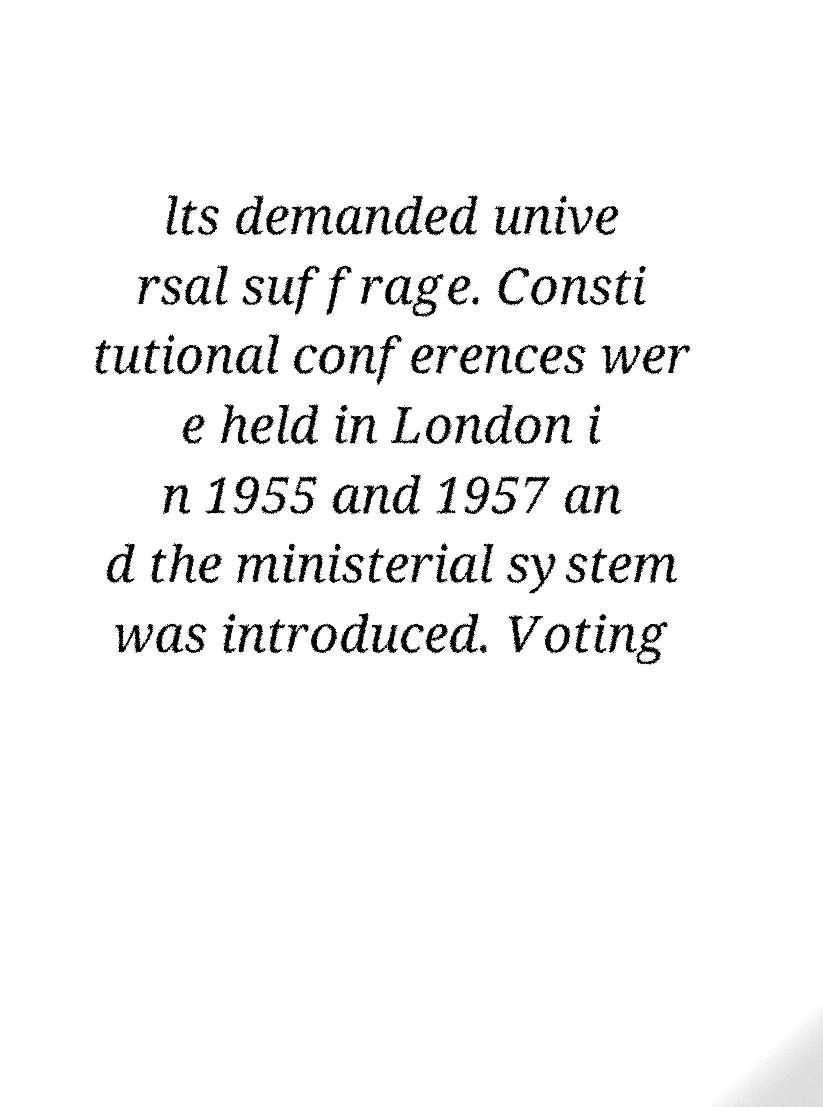For documentation purposes, I need the text within this image transcribed. Could you provide that? lts demanded unive rsal suffrage. Consti tutional conferences wer e held in London i n 1955 and 1957 an d the ministerial system was introduced. Voting 